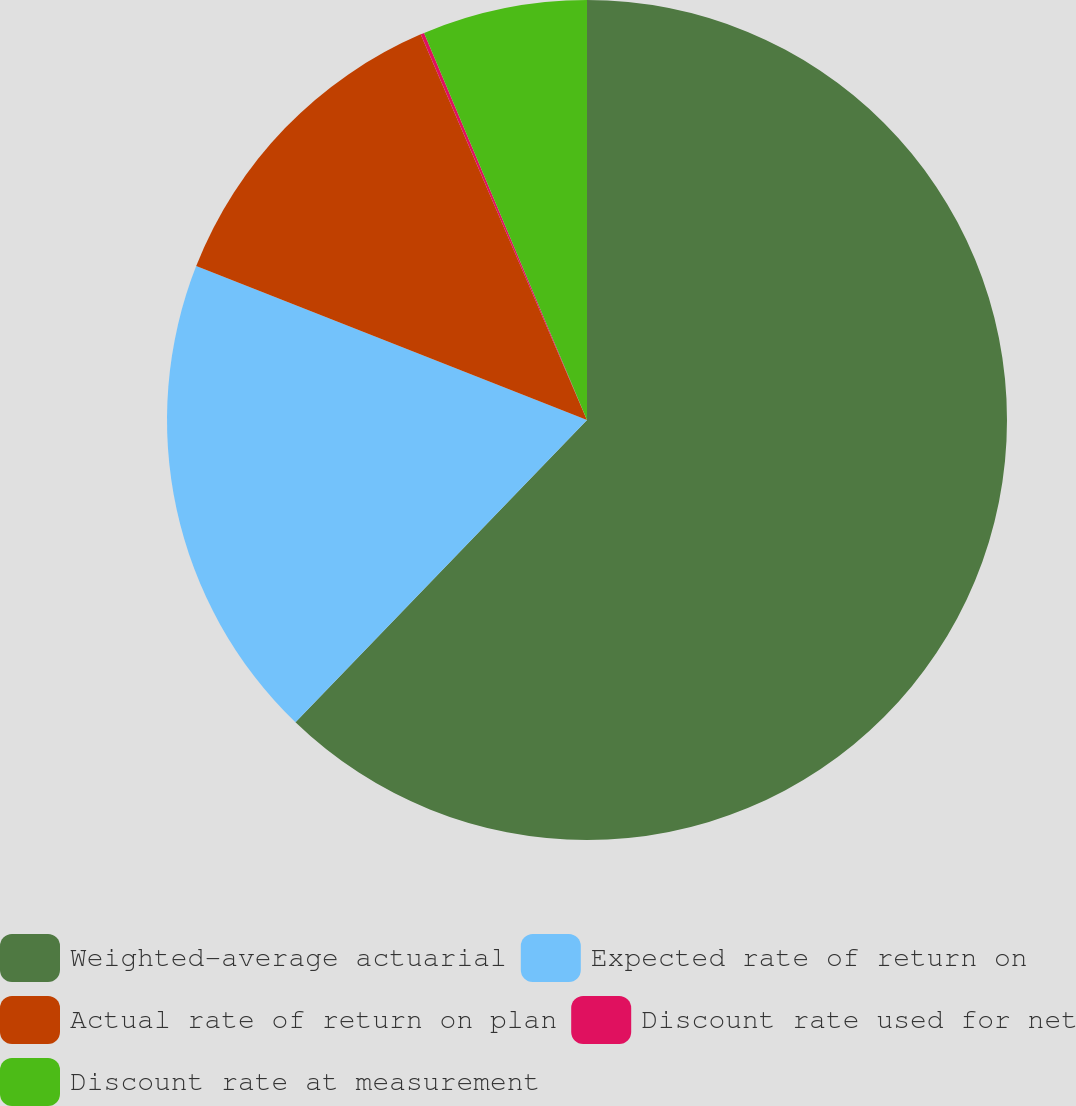Convert chart. <chart><loc_0><loc_0><loc_500><loc_500><pie_chart><fcel>Weighted-average actuarial<fcel>Expected rate of return on<fcel>Actual rate of return on plan<fcel>Discount rate used for net<fcel>Discount rate at measurement<nl><fcel>62.21%<fcel>18.76%<fcel>12.55%<fcel>0.14%<fcel>6.34%<nl></chart> 